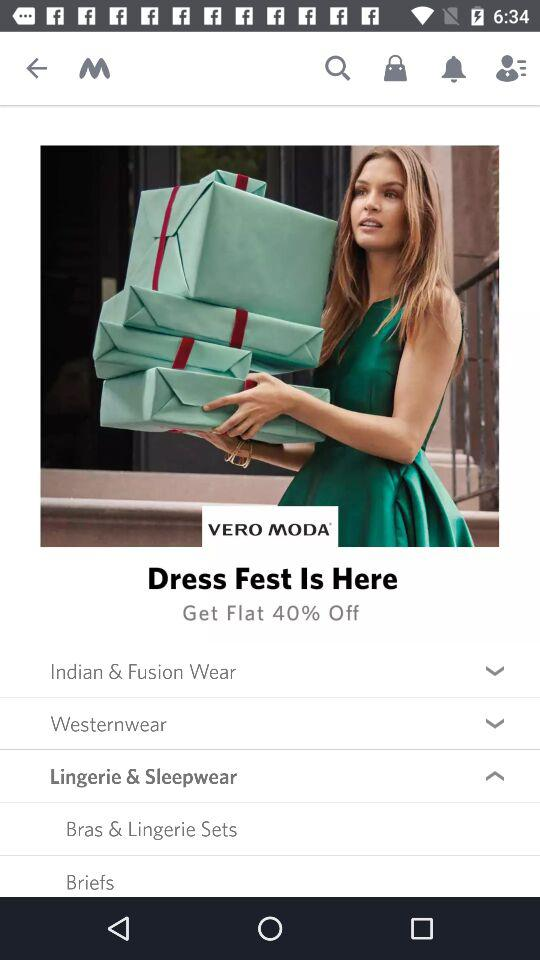What is the name of the clothing brand given? The name of the clothing brand is "VERO MODA". 